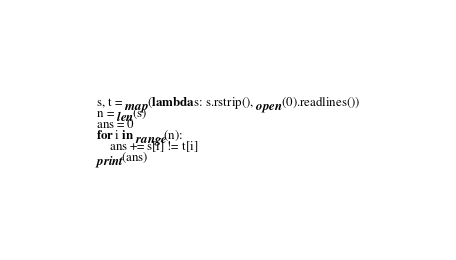<code> <loc_0><loc_0><loc_500><loc_500><_Python_>s, t = map(lambda s: s.rstrip(), open(0).readlines())
n = len(s)
ans = 0
for i in range(n):
    ans += s[i] != t[i]
print(ans)
</code> 